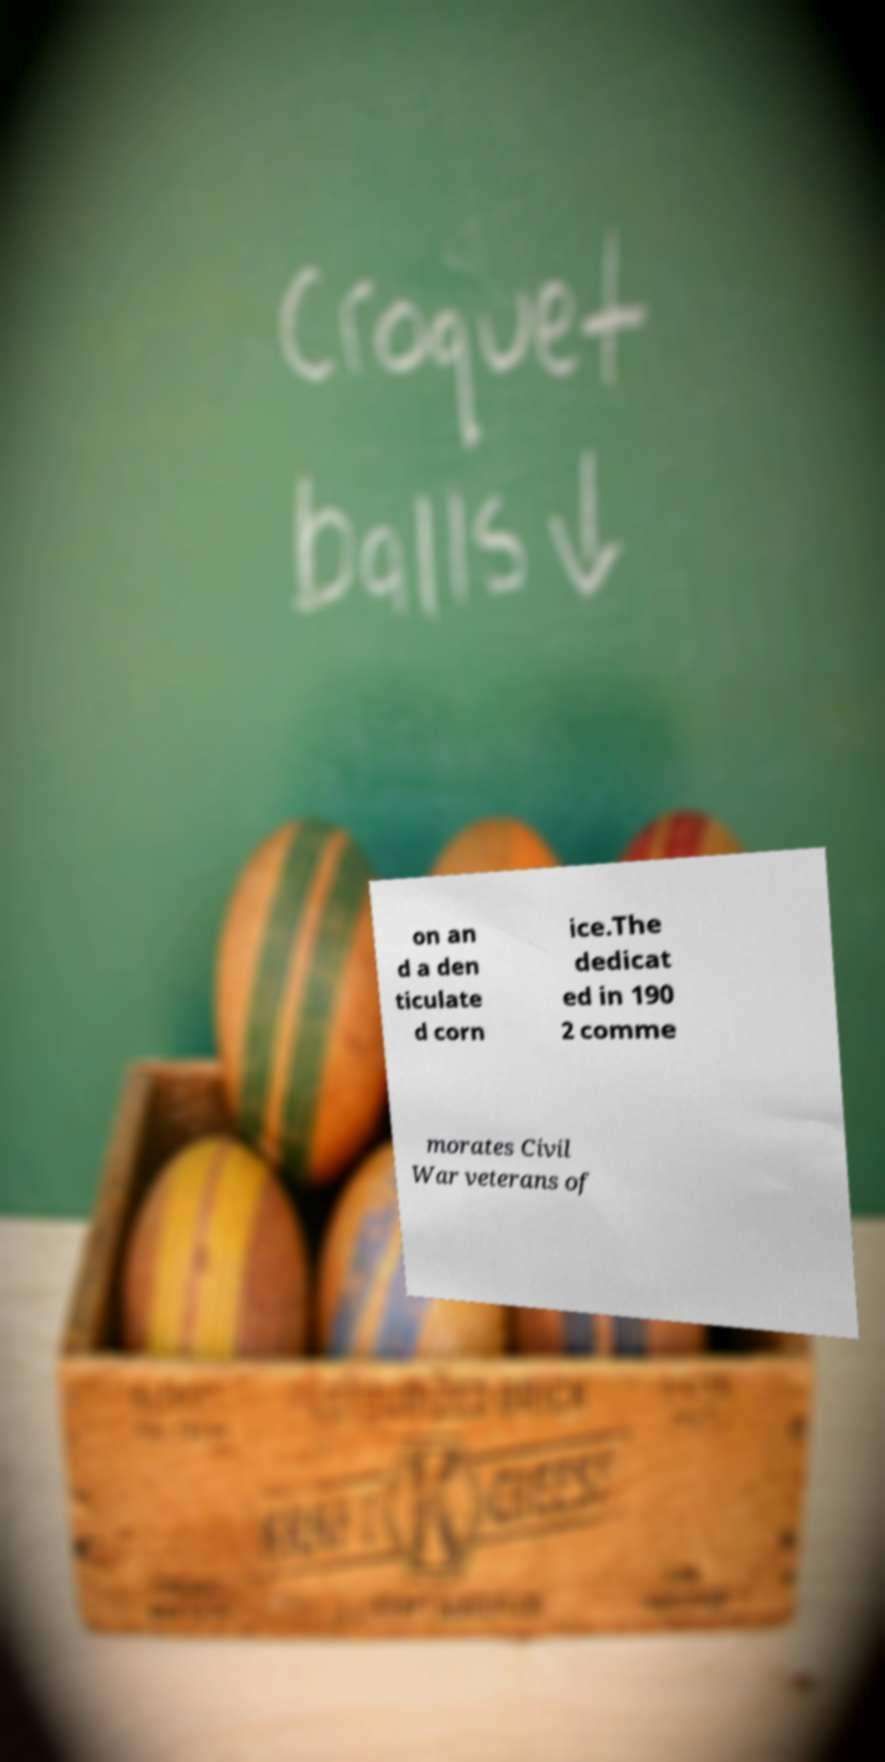For documentation purposes, I need the text within this image transcribed. Could you provide that? on an d a den ticulate d corn ice.The dedicat ed in 190 2 comme morates Civil War veterans of 